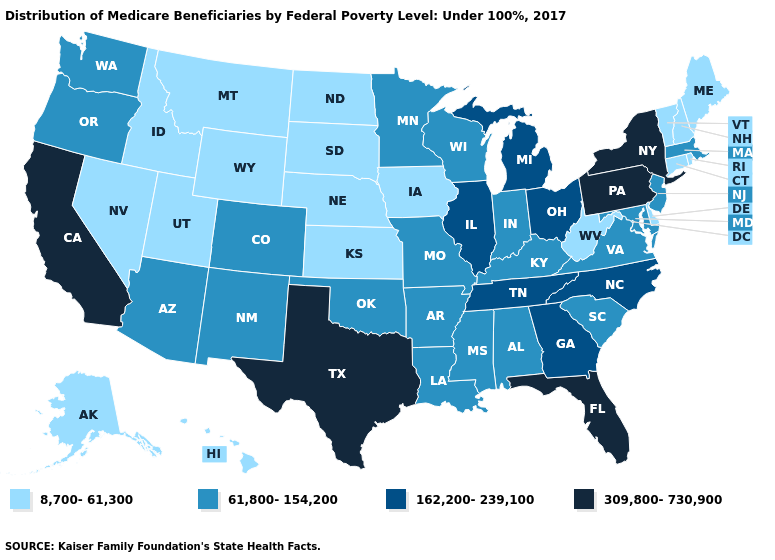Among the states that border Arkansas , which have the highest value?
Concise answer only. Texas. Name the states that have a value in the range 162,200-239,100?
Write a very short answer. Georgia, Illinois, Michigan, North Carolina, Ohio, Tennessee. Among the states that border Rhode Island , which have the highest value?
Concise answer only. Massachusetts. What is the value of Texas?
Keep it brief. 309,800-730,900. How many symbols are there in the legend?
Give a very brief answer. 4. Which states hav the highest value in the Northeast?
Answer briefly. New York, Pennsylvania. What is the lowest value in states that border Kentucky?
Quick response, please. 8,700-61,300. Among the states that border North Carolina , which have the lowest value?
Keep it brief. South Carolina, Virginia. Which states hav the highest value in the MidWest?
Answer briefly. Illinois, Michigan, Ohio. Does Kansas have the highest value in the MidWest?
Answer briefly. No. Name the states that have a value in the range 61,800-154,200?
Answer briefly. Alabama, Arizona, Arkansas, Colorado, Indiana, Kentucky, Louisiana, Maryland, Massachusetts, Minnesota, Mississippi, Missouri, New Jersey, New Mexico, Oklahoma, Oregon, South Carolina, Virginia, Washington, Wisconsin. Does the first symbol in the legend represent the smallest category?
Concise answer only. Yes. Does the first symbol in the legend represent the smallest category?
Concise answer only. Yes. Which states have the highest value in the USA?
Concise answer only. California, Florida, New York, Pennsylvania, Texas. Name the states that have a value in the range 162,200-239,100?
Short answer required. Georgia, Illinois, Michigan, North Carolina, Ohio, Tennessee. 